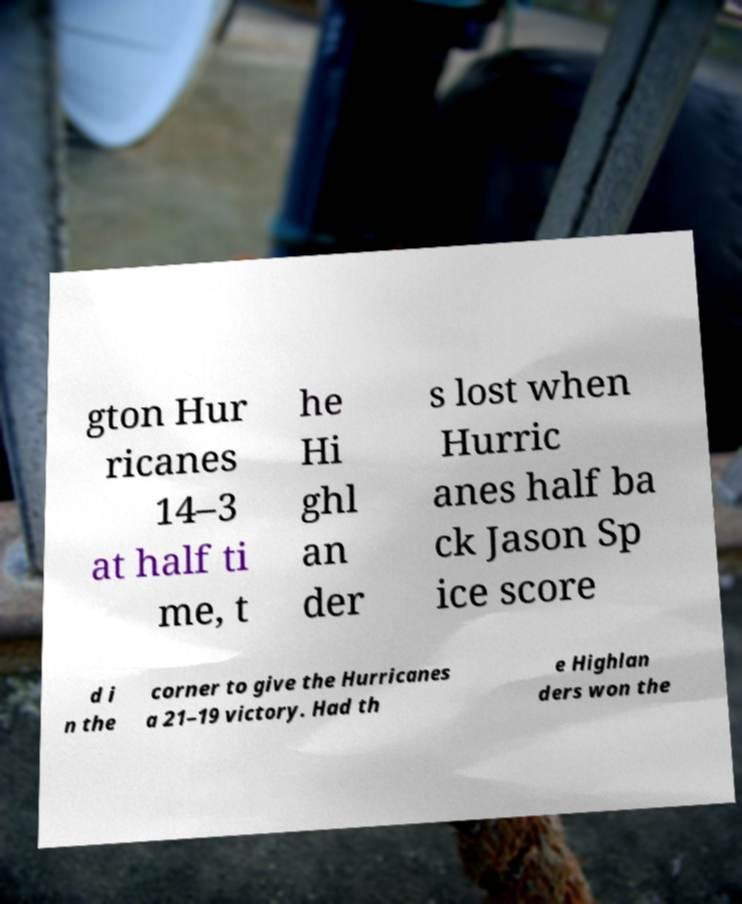Could you extract and type out the text from this image? gton Hur ricanes 14–3 at half ti me, t he Hi ghl an der s lost when Hurric anes half ba ck Jason Sp ice score d i n the corner to give the Hurricanes a 21–19 victory. Had th e Highlan ders won the 